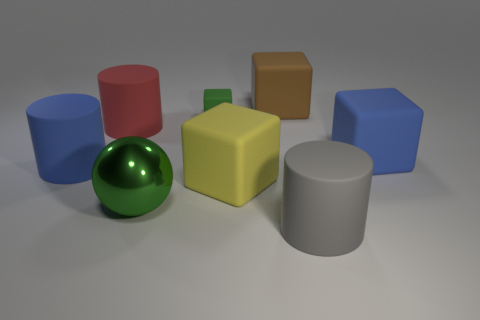Subtract all large blue cylinders. How many cylinders are left? 2 Subtract all blue cubes. How many cubes are left? 3 Subtract all spheres. How many objects are left? 7 Subtract all large cyan matte cubes. Subtract all big blue cylinders. How many objects are left? 7 Add 5 yellow matte blocks. How many yellow matte blocks are left? 6 Add 1 small blue matte spheres. How many small blue matte spheres exist? 1 Add 2 tiny yellow things. How many objects exist? 10 Subtract 0 brown cylinders. How many objects are left? 8 Subtract 2 cylinders. How many cylinders are left? 1 Subtract all purple cubes. Subtract all purple cylinders. How many cubes are left? 4 